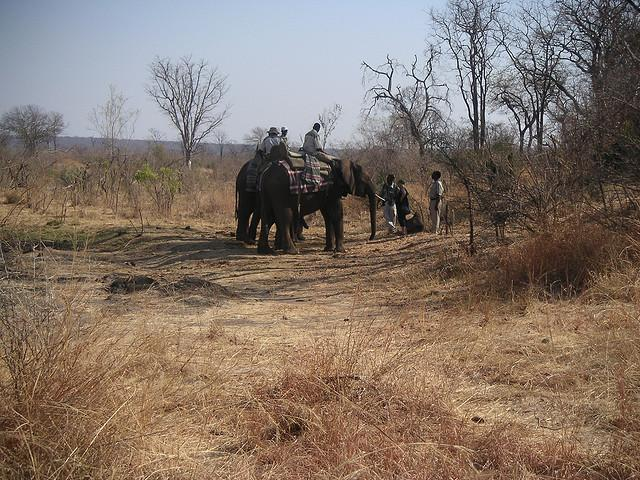Why is there a saddle on the elephant?

Choices:
A) as decoration
B) to ride
C) to buy
D) to sell to ride 